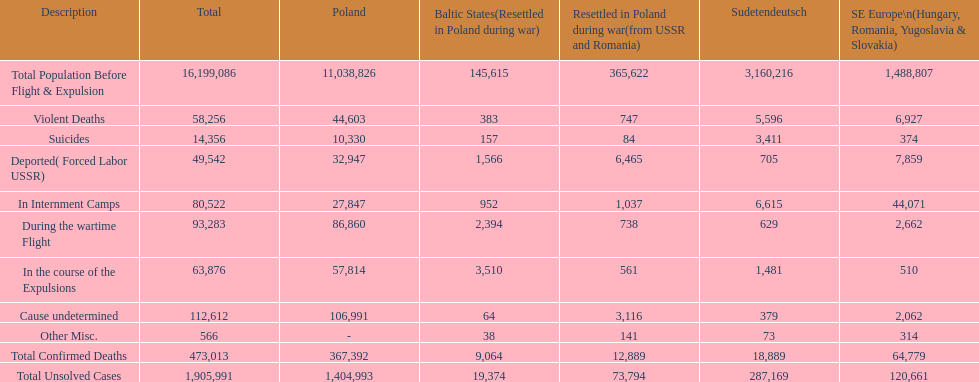What was the cause of the most deaths? Cause undetermined. I'm looking to parse the entire table for insights. Could you assist me with that? {'header': ['Description', 'Total', 'Poland', 'Baltic States(Resettled in Poland during war)', 'Resettled in Poland during war(from USSR and Romania)', 'Sudetendeutsch', 'SE Europe\\n(Hungary, Romania, Yugoslavia & Slovakia)'], 'rows': [['Total Population Before Flight & Expulsion', '16,199,086', '11,038,826', '145,615', '365,622', '3,160,216', '1,488,807'], ['Violent Deaths', '58,256', '44,603', '383', '747', '5,596', '6,927'], ['Suicides', '14,356', '10,330', '157', '84', '3,411', '374'], ['Deported( Forced Labor USSR)', '49,542', '32,947', '1,566', '6,465', '705', '7,859'], ['In Internment Camps', '80,522', '27,847', '952', '1,037', '6,615', '44,071'], ['During the wartime Flight', '93,283', '86,860', '2,394', '738', '629', '2,662'], ['In the course of the Expulsions', '63,876', '57,814', '3,510', '561', '1,481', '510'], ['Cause undetermined', '112,612', '106,991', '64', '3,116', '379', '2,062'], ['Other Misc.', '566', '-', '38', '141', '73', '314'], ['Total Confirmed Deaths', '473,013', '367,392', '9,064', '12,889', '18,889', '64,779'], ['Total Unsolved Cases', '1,905,991', '1,404,993', '19,374', '73,794', '287,169', '120,661']]} 